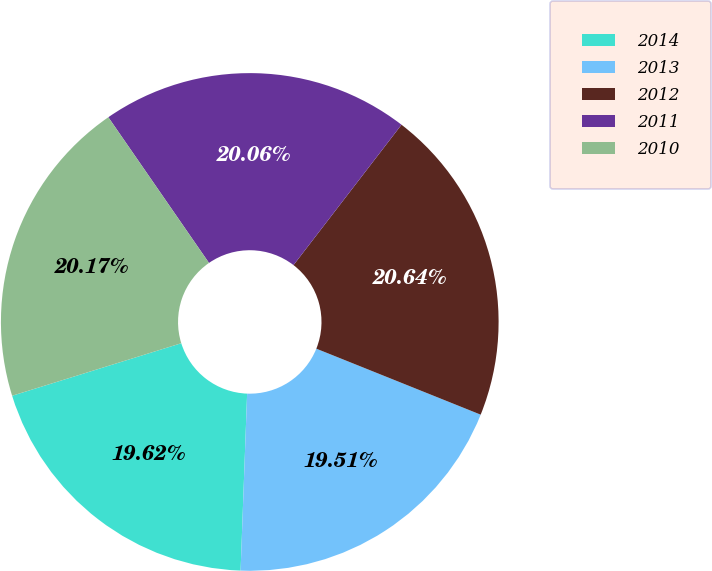Convert chart to OTSL. <chart><loc_0><loc_0><loc_500><loc_500><pie_chart><fcel>2014<fcel>2013<fcel>2012<fcel>2011<fcel>2010<nl><fcel>19.62%<fcel>19.51%<fcel>20.64%<fcel>20.06%<fcel>20.17%<nl></chart> 